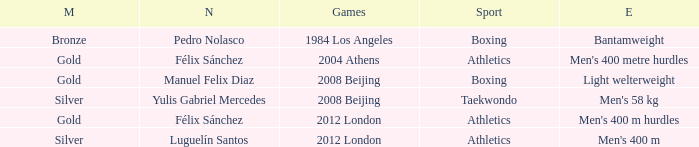What Medal had a Name of manuel felix diaz? Gold. 